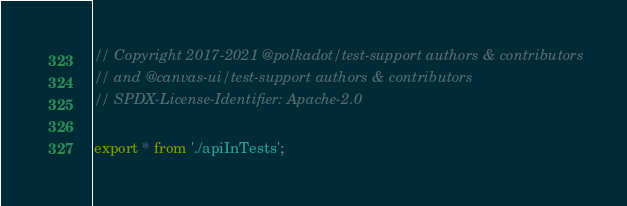Convert code to text. <code><loc_0><loc_0><loc_500><loc_500><_TypeScript_>// Copyright 2017-2021 @polkadot/test-support authors & contributors
// and @canvas-ui/test-support authors & contributors
// SPDX-License-Identifier: Apache-2.0

export * from './apiInTests';
</code> 